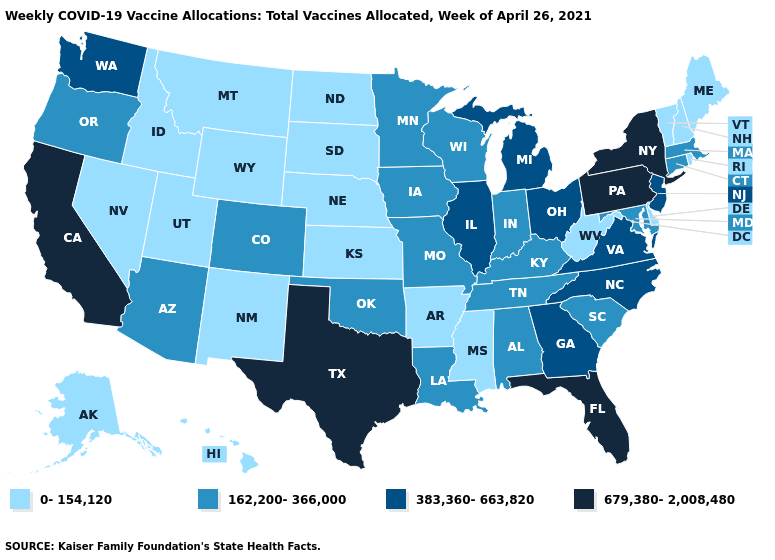Among the states that border Utah , does Colorado have the highest value?
Be succinct. Yes. Which states have the highest value in the USA?
Give a very brief answer. California, Florida, New York, Pennsylvania, Texas. What is the highest value in the MidWest ?
Write a very short answer. 383,360-663,820. What is the lowest value in the USA?
Be succinct. 0-154,120. Does the first symbol in the legend represent the smallest category?
Be succinct. Yes. Name the states that have a value in the range 383,360-663,820?
Write a very short answer. Georgia, Illinois, Michigan, New Jersey, North Carolina, Ohio, Virginia, Washington. Which states have the lowest value in the West?
Write a very short answer. Alaska, Hawaii, Idaho, Montana, Nevada, New Mexico, Utah, Wyoming. Among the states that border Minnesota , which have the lowest value?
Keep it brief. North Dakota, South Dakota. Name the states that have a value in the range 162,200-366,000?
Short answer required. Alabama, Arizona, Colorado, Connecticut, Indiana, Iowa, Kentucky, Louisiana, Maryland, Massachusetts, Minnesota, Missouri, Oklahoma, Oregon, South Carolina, Tennessee, Wisconsin. Does Minnesota have a lower value than New York?
Keep it brief. Yes. Does Alabama have a higher value than Georgia?
Write a very short answer. No. Name the states that have a value in the range 383,360-663,820?
Short answer required. Georgia, Illinois, Michigan, New Jersey, North Carolina, Ohio, Virginia, Washington. What is the value of Montana?
Concise answer only. 0-154,120. What is the lowest value in states that border New Hampshire?
Keep it brief. 0-154,120. What is the highest value in states that border Iowa?
Give a very brief answer. 383,360-663,820. 